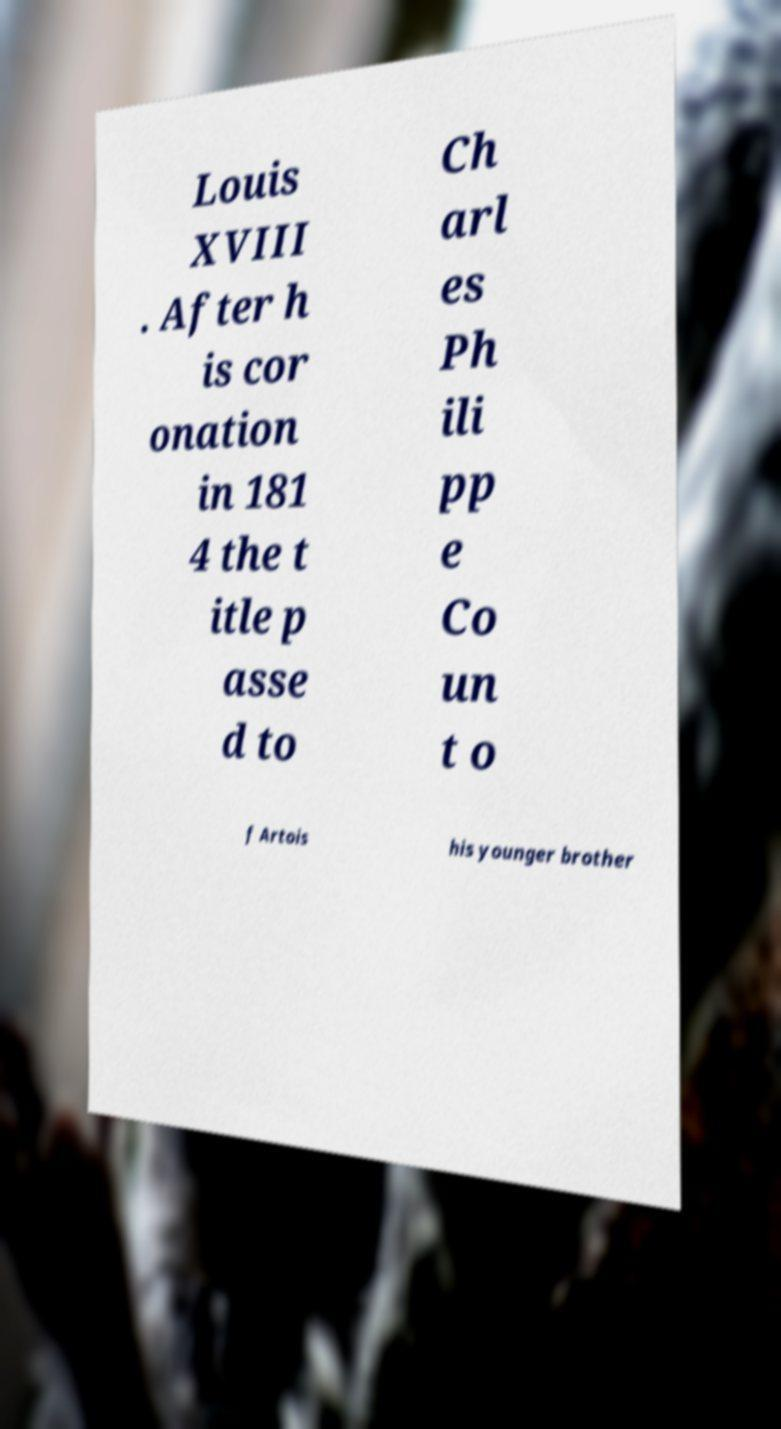For documentation purposes, I need the text within this image transcribed. Could you provide that? Louis XVIII . After h is cor onation in 181 4 the t itle p asse d to Ch arl es Ph ili pp e Co un t o f Artois his younger brother 